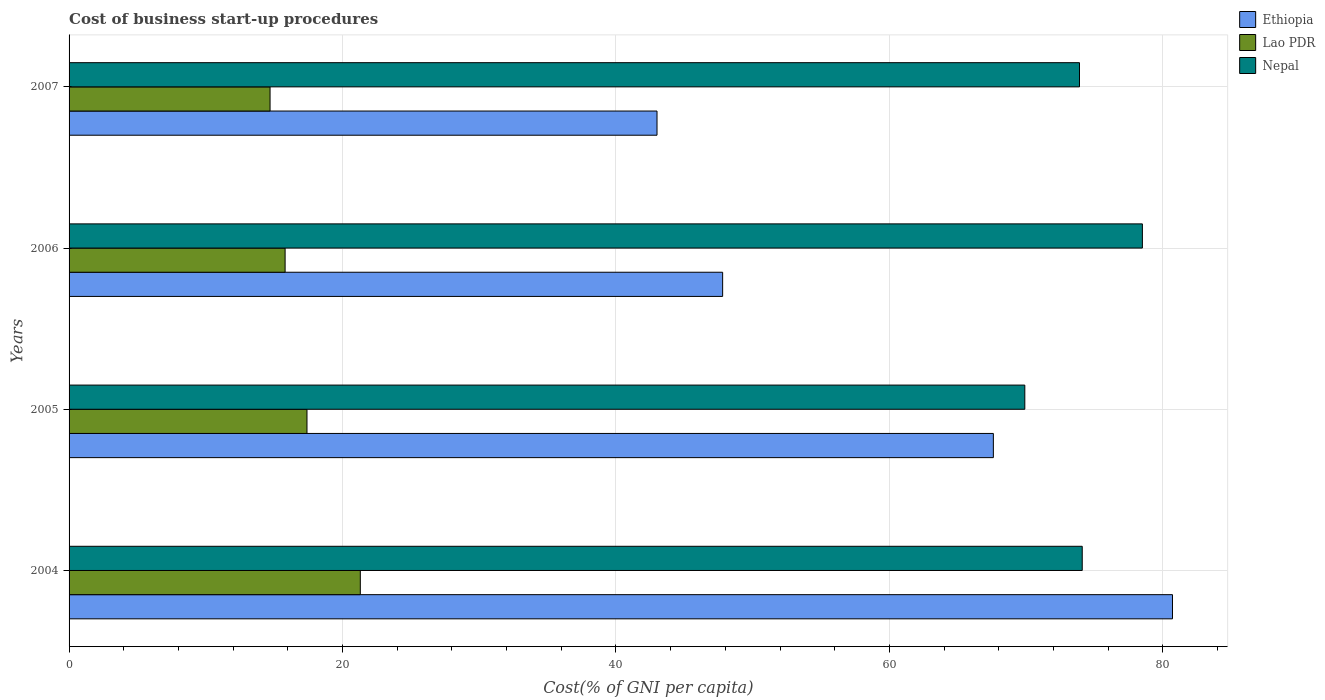Are the number of bars per tick equal to the number of legend labels?
Provide a short and direct response. Yes. How many bars are there on the 4th tick from the top?
Offer a terse response. 3. How many bars are there on the 1st tick from the bottom?
Provide a short and direct response. 3. What is the label of the 1st group of bars from the top?
Your response must be concise. 2007. What is the cost of business start-up procedures in Nepal in 2004?
Keep it short and to the point. 74.1. Across all years, what is the maximum cost of business start-up procedures in Ethiopia?
Ensure brevity in your answer.  80.7. Across all years, what is the minimum cost of business start-up procedures in Nepal?
Ensure brevity in your answer.  69.9. What is the total cost of business start-up procedures in Nepal in the graph?
Your answer should be compact. 296.4. What is the difference between the cost of business start-up procedures in Ethiopia in 2006 and that in 2007?
Keep it short and to the point. 4.8. What is the difference between the cost of business start-up procedures in Lao PDR in 2005 and the cost of business start-up procedures in Nepal in 2007?
Provide a short and direct response. -56.5. What is the average cost of business start-up procedures in Nepal per year?
Give a very brief answer. 74.1. In the year 2006, what is the difference between the cost of business start-up procedures in Nepal and cost of business start-up procedures in Lao PDR?
Give a very brief answer. 62.7. In how many years, is the cost of business start-up procedures in Nepal greater than 80 %?
Make the answer very short. 0. What is the ratio of the cost of business start-up procedures in Nepal in 2004 to that in 2005?
Provide a short and direct response. 1.06. Is the difference between the cost of business start-up procedures in Nepal in 2005 and 2007 greater than the difference between the cost of business start-up procedures in Lao PDR in 2005 and 2007?
Ensure brevity in your answer.  No. What is the difference between the highest and the second highest cost of business start-up procedures in Ethiopia?
Your answer should be very brief. 13.1. What is the difference between the highest and the lowest cost of business start-up procedures in Ethiopia?
Make the answer very short. 37.7. Is the sum of the cost of business start-up procedures in Nepal in 2004 and 2006 greater than the maximum cost of business start-up procedures in Ethiopia across all years?
Give a very brief answer. Yes. What does the 2nd bar from the top in 2004 represents?
Provide a succinct answer. Lao PDR. What does the 2nd bar from the bottom in 2006 represents?
Provide a succinct answer. Lao PDR. How many bars are there?
Offer a terse response. 12. What is the difference between two consecutive major ticks on the X-axis?
Your response must be concise. 20. Are the values on the major ticks of X-axis written in scientific E-notation?
Make the answer very short. No. Does the graph contain any zero values?
Offer a very short reply. No. Where does the legend appear in the graph?
Your answer should be compact. Top right. What is the title of the graph?
Make the answer very short. Cost of business start-up procedures. What is the label or title of the X-axis?
Offer a terse response. Cost(% of GNI per capita). What is the Cost(% of GNI per capita) of Ethiopia in 2004?
Provide a succinct answer. 80.7. What is the Cost(% of GNI per capita) of Lao PDR in 2004?
Offer a very short reply. 21.3. What is the Cost(% of GNI per capita) of Nepal in 2004?
Offer a terse response. 74.1. What is the Cost(% of GNI per capita) of Ethiopia in 2005?
Ensure brevity in your answer.  67.6. What is the Cost(% of GNI per capita) of Nepal in 2005?
Your answer should be compact. 69.9. What is the Cost(% of GNI per capita) in Ethiopia in 2006?
Your answer should be compact. 47.8. What is the Cost(% of GNI per capita) in Lao PDR in 2006?
Give a very brief answer. 15.8. What is the Cost(% of GNI per capita) in Nepal in 2006?
Provide a short and direct response. 78.5. What is the Cost(% of GNI per capita) in Ethiopia in 2007?
Provide a succinct answer. 43. What is the Cost(% of GNI per capita) of Lao PDR in 2007?
Give a very brief answer. 14.7. What is the Cost(% of GNI per capita) of Nepal in 2007?
Provide a succinct answer. 73.9. Across all years, what is the maximum Cost(% of GNI per capita) in Ethiopia?
Make the answer very short. 80.7. Across all years, what is the maximum Cost(% of GNI per capita) in Lao PDR?
Your answer should be very brief. 21.3. Across all years, what is the maximum Cost(% of GNI per capita) in Nepal?
Your answer should be very brief. 78.5. Across all years, what is the minimum Cost(% of GNI per capita) in Nepal?
Provide a succinct answer. 69.9. What is the total Cost(% of GNI per capita) of Ethiopia in the graph?
Give a very brief answer. 239.1. What is the total Cost(% of GNI per capita) in Lao PDR in the graph?
Keep it short and to the point. 69.2. What is the total Cost(% of GNI per capita) of Nepal in the graph?
Provide a short and direct response. 296.4. What is the difference between the Cost(% of GNI per capita) of Ethiopia in 2004 and that in 2005?
Your answer should be very brief. 13.1. What is the difference between the Cost(% of GNI per capita) in Lao PDR in 2004 and that in 2005?
Give a very brief answer. 3.9. What is the difference between the Cost(% of GNI per capita) in Nepal in 2004 and that in 2005?
Ensure brevity in your answer.  4.2. What is the difference between the Cost(% of GNI per capita) of Ethiopia in 2004 and that in 2006?
Provide a succinct answer. 32.9. What is the difference between the Cost(% of GNI per capita) in Ethiopia in 2004 and that in 2007?
Give a very brief answer. 37.7. What is the difference between the Cost(% of GNI per capita) of Lao PDR in 2004 and that in 2007?
Keep it short and to the point. 6.6. What is the difference between the Cost(% of GNI per capita) of Ethiopia in 2005 and that in 2006?
Your answer should be very brief. 19.8. What is the difference between the Cost(% of GNI per capita) in Lao PDR in 2005 and that in 2006?
Ensure brevity in your answer.  1.6. What is the difference between the Cost(% of GNI per capita) of Ethiopia in 2005 and that in 2007?
Your answer should be compact. 24.6. What is the difference between the Cost(% of GNI per capita) of Lao PDR in 2005 and that in 2007?
Your answer should be compact. 2.7. What is the difference between the Cost(% of GNI per capita) in Nepal in 2005 and that in 2007?
Provide a succinct answer. -4. What is the difference between the Cost(% of GNI per capita) in Ethiopia in 2006 and that in 2007?
Ensure brevity in your answer.  4.8. What is the difference between the Cost(% of GNI per capita) of Nepal in 2006 and that in 2007?
Provide a succinct answer. 4.6. What is the difference between the Cost(% of GNI per capita) of Ethiopia in 2004 and the Cost(% of GNI per capita) of Lao PDR in 2005?
Your answer should be compact. 63.3. What is the difference between the Cost(% of GNI per capita) in Lao PDR in 2004 and the Cost(% of GNI per capita) in Nepal in 2005?
Make the answer very short. -48.6. What is the difference between the Cost(% of GNI per capita) in Ethiopia in 2004 and the Cost(% of GNI per capita) in Lao PDR in 2006?
Your answer should be very brief. 64.9. What is the difference between the Cost(% of GNI per capita) in Ethiopia in 2004 and the Cost(% of GNI per capita) in Nepal in 2006?
Provide a short and direct response. 2.2. What is the difference between the Cost(% of GNI per capita) of Lao PDR in 2004 and the Cost(% of GNI per capita) of Nepal in 2006?
Ensure brevity in your answer.  -57.2. What is the difference between the Cost(% of GNI per capita) in Ethiopia in 2004 and the Cost(% of GNI per capita) in Lao PDR in 2007?
Ensure brevity in your answer.  66. What is the difference between the Cost(% of GNI per capita) in Lao PDR in 2004 and the Cost(% of GNI per capita) in Nepal in 2007?
Make the answer very short. -52.6. What is the difference between the Cost(% of GNI per capita) in Ethiopia in 2005 and the Cost(% of GNI per capita) in Lao PDR in 2006?
Offer a terse response. 51.8. What is the difference between the Cost(% of GNI per capita) of Lao PDR in 2005 and the Cost(% of GNI per capita) of Nepal in 2006?
Keep it short and to the point. -61.1. What is the difference between the Cost(% of GNI per capita) in Ethiopia in 2005 and the Cost(% of GNI per capita) in Lao PDR in 2007?
Make the answer very short. 52.9. What is the difference between the Cost(% of GNI per capita) of Lao PDR in 2005 and the Cost(% of GNI per capita) of Nepal in 2007?
Your answer should be compact. -56.5. What is the difference between the Cost(% of GNI per capita) in Ethiopia in 2006 and the Cost(% of GNI per capita) in Lao PDR in 2007?
Provide a succinct answer. 33.1. What is the difference between the Cost(% of GNI per capita) of Ethiopia in 2006 and the Cost(% of GNI per capita) of Nepal in 2007?
Your answer should be compact. -26.1. What is the difference between the Cost(% of GNI per capita) in Lao PDR in 2006 and the Cost(% of GNI per capita) in Nepal in 2007?
Your answer should be compact. -58.1. What is the average Cost(% of GNI per capita) of Ethiopia per year?
Offer a terse response. 59.77. What is the average Cost(% of GNI per capita) of Nepal per year?
Your answer should be compact. 74.1. In the year 2004, what is the difference between the Cost(% of GNI per capita) in Ethiopia and Cost(% of GNI per capita) in Lao PDR?
Your response must be concise. 59.4. In the year 2004, what is the difference between the Cost(% of GNI per capita) in Ethiopia and Cost(% of GNI per capita) in Nepal?
Give a very brief answer. 6.6. In the year 2004, what is the difference between the Cost(% of GNI per capita) in Lao PDR and Cost(% of GNI per capita) in Nepal?
Make the answer very short. -52.8. In the year 2005, what is the difference between the Cost(% of GNI per capita) in Ethiopia and Cost(% of GNI per capita) in Lao PDR?
Give a very brief answer. 50.2. In the year 2005, what is the difference between the Cost(% of GNI per capita) of Lao PDR and Cost(% of GNI per capita) of Nepal?
Your answer should be compact. -52.5. In the year 2006, what is the difference between the Cost(% of GNI per capita) of Ethiopia and Cost(% of GNI per capita) of Lao PDR?
Offer a very short reply. 32. In the year 2006, what is the difference between the Cost(% of GNI per capita) of Ethiopia and Cost(% of GNI per capita) of Nepal?
Your response must be concise. -30.7. In the year 2006, what is the difference between the Cost(% of GNI per capita) in Lao PDR and Cost(% of GNI per capita) in Nepal?
Ensure brevity in your answer.  -62.7. In the year 2007, what is the difference between the Cost(% of GNI per capita) of Ethiopia and Cost(% of GNI per capita) of Lao PDR?
Ensure brevity in your answer.  28.3. In the year 2007, what is the difference between the Cost(% of GNI per capita) of Ethiopia and Cost(% of GNI per capita) of Nepal?
Make the answer very short. -30.9. In the year 2007, what is the difference between the Cost(% of GNI per capita) in Lao PDR and Cost(% of GNI per capita) in Nepal?
Give a very brief answer. -59.2. What is the ratio of the Cost(% of GNI per capita) in Ethiopia in 2004 to that in 2005?
Ensure brevity in your answer.  1.19. What is the ratio of the Cost(% of GNI per capita) in Lao PDR in 2004 to that in 2005?
Make the answer very short. 1.22. What is the ratio of the Cost(% of GNI per capita) of Nepal in 2004 to that in 2005?
Provide a short and direct response. 1.06. What is the ratio of the Cost(% of GNI per capita) in Ethiopia in 2004 to that in 2006?
Your response must be concise. 1.69. What is the ratio of the Cost(% of GNI per capita) of Lao PDR in 2004 to that in 2006?
Your response must be concise. 1.35. What is the ratio of the Cost(% of GNI per capita) in Nepal in 2004 to that in 2006?
Make the answer very short. 0.94. What is the ratio of the Cost(% of GNI per capita) of Ethiopia in 2004 to that in 2007?
Keep it short and to the point. 1.88. What is the ratio of the Cost(% of GNI per capita) of Lao PDR in 2004 to that in 2007?
Give a very brief answer. 1.45. What is the ratio of the Cost(% of GNI per capita) in Nepal in 2004 to that in 2007?
Your answer should be very brief. 1. What is the ratio of the Cost(% of GNI per capita) in Ethiopia in 2005 to that in 2006?
Your answer should be very brief. 1.41. What is the ratio of the Cost(% of GNI per capita) of Lao PDR in 2005 to that in 2006?
Your answer should be compact. 1.1. What is the ratio of the Cost(% of GNI per capita) in Nepal in 2005 to that in 2006?
Your response must be concise. 0.89. What is the ratio of the Cost(% of GNI per capita) in Ethiopia in 2005 to that in 2007?
Ensure brevity in your answer.  1.57. What is the ratio of the Cost(% of GNI per capita) of Lao PDR in 2005 to that in 2007?
Give a very brief answer. 1.18. What is the ratio of the Cost(% of GNI per capita) of Nepal in 2005 to that in 2007?
Offer a terse response. 0.95. What is the ratio of the Cost(% of GNI per capita) of Ethiopia in 2006 to that in 2007?
Give a very brief answer. 1.11. What is the ratio of the Cost(% of GNI per capita) in Lao PDR in 2006 to that in 2007?
Give a very brief answer. 1.07. What is the ratio of the Cost(% of GNI per capita) of Nepal in 2006 to that in 2007?
Your answer should be very brief. 1.06. What is the difference between the highest and the second highest Cost(% of GNI per capita) in Nepal?
Ensure brevity in your answer.  4.4. What is the difference between the highest and the lowest Cost(% of GNI per capita) of Ethiopia?
Your response must be concise. 37.7. What is the difference between the highest and the lowest Cost(% of GNI per capita) of Nepal?
Make the answer very short. 8.6. 